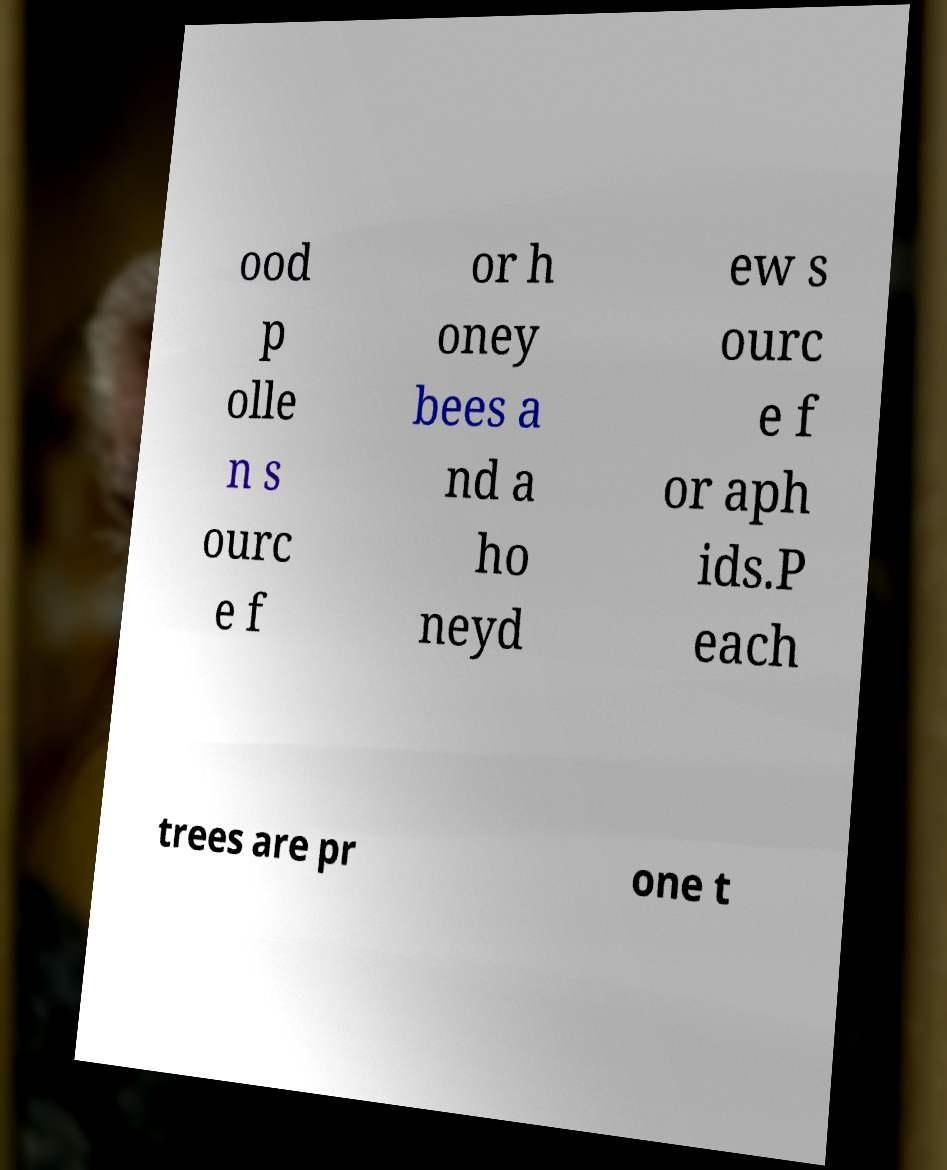Please identify and transcribe the text found in this image. ood p olle n s ourc e f or h oney bees a nd a ho neyd ew s ourc e f or aph ids.P each trees are pr one t 